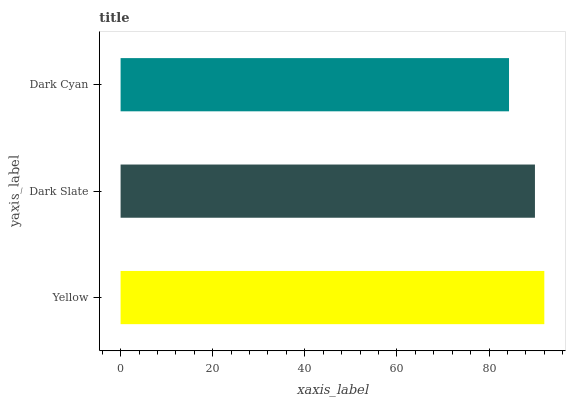Is Dark Cyan the minimum?
Answer yes or no. Yes. Is Yellow the maximum?
Answer yes or no. Yes. Is Dark Slate the minimum?
Answer yes or no. No. Is Dark Slate the maximum?
Answer yes or no. No. Is Yellow greater than Dark Slate?
Answer yes or no. Yes. Is Dark Slate less than Yellow?
Answer yes or no. Yes. Is Dark Slate greater than Yellow?
Answer yes or no. No. Is Yellow less than Dark Slate?
Answer yes or no. No. Is Dark Slate the high median?
Answer yes or no. Yes. Is Dark Slate the low median?
Answer yes or no. Yes. Is Dark Cyan the high median?
Answer yes or no. No. Is Dark Cyan the low median?
Answer yes or no. No. 